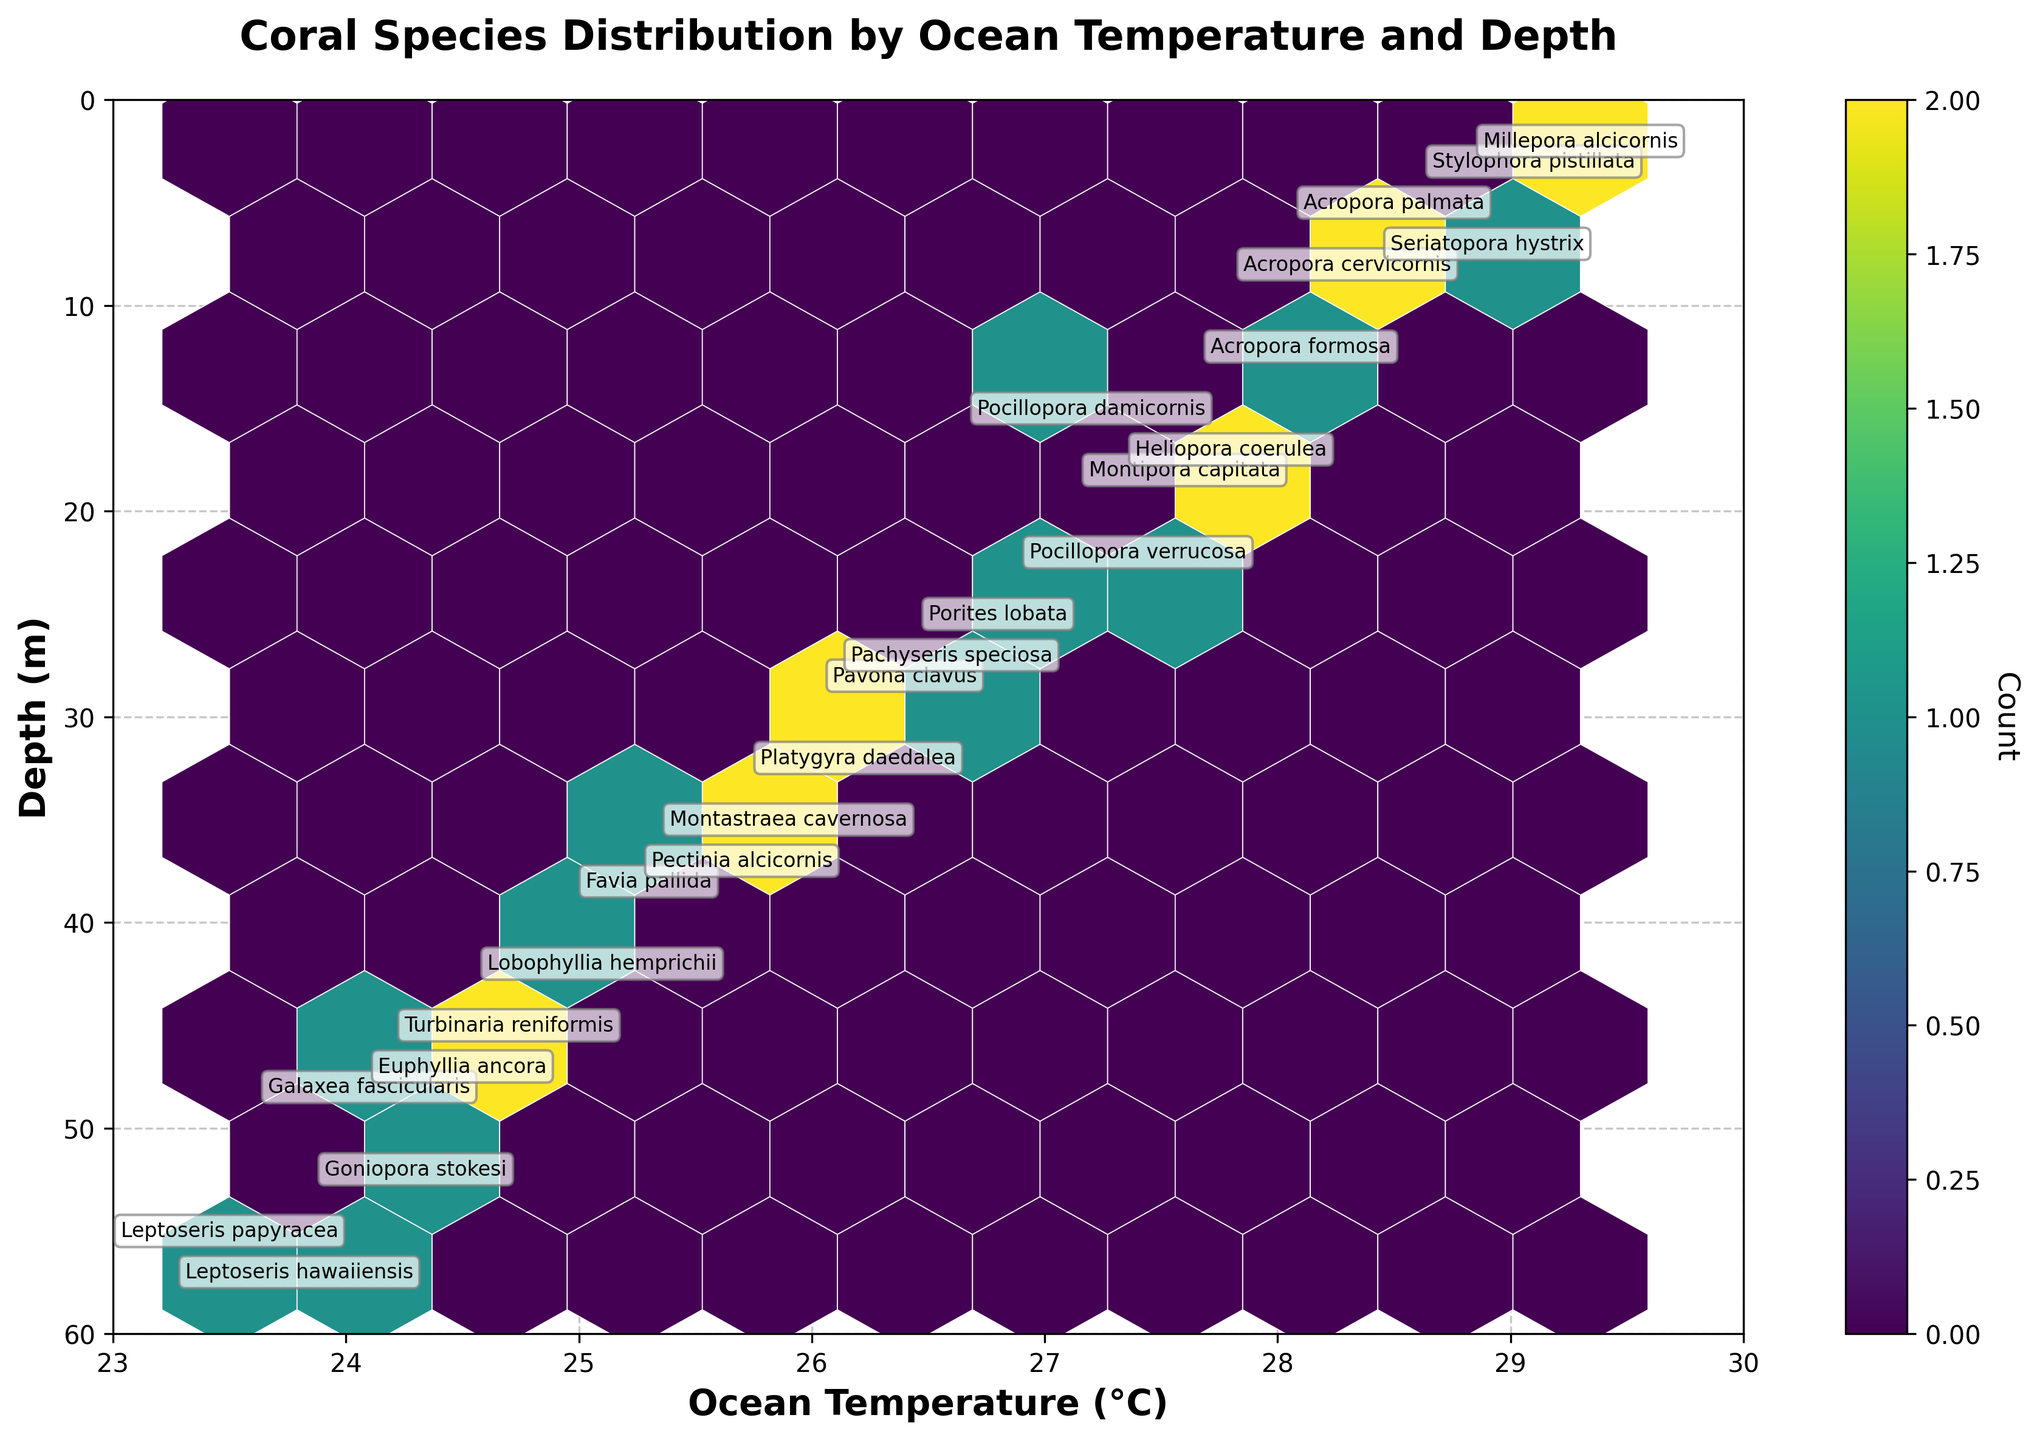What is the title of the plot? The title is always placed at the top center of the plot. In this case, it is written in bold and larger font to stand out and convey the main subject of the data visualization.
Answer: Coral Species Distribution by Ocean Temperature and Depth What are the axes labels and their units? The x-axis label is "Ocean Temperature (°C)" showing temperature in degrees Celsius, and the y-axis label is "Depth (m)" showing depth in meters. Generally, axis labels provide context for what each axis represents in the plot.
Answer: Ocean Temperature (°C) and Depth (m) How many bins are in the hexbin plot? Counting the number of hexagonal cells displayed, taking into account the grid size defined in the plot scenario. Each hexagon can be seen where data points are aggregated based on proximity.
Answer: 10 Which coral species appears deepest in the plot? By looking at the plot vertically down to find the lowest y-axis value where a species annotation is present, you can determine the deepest occurring species.
Answer: Leptoseris hawaiiensis Which temperature range has the highest density of corals? Identifying the temperature range with the most densely packed bins; areas where hexagons are darkest or most concentrated. This requires analyzing the coloration intensity of the hexagonal bins along the x-axis.
Answer: 27°C to 29°C Which coral species is found at the shallowest depth? Observing the highest point on the y-axis where a species annotation is made will indicate the shallowest depth of a particular species.
Answer: Millepora alcicornis Compare the distribution pattern of corals at 28°C versus 24°C. By focusing on the points and hexbin densities at the mentioned temperatures, observe where and how the corals are distributed across the depth, interpreting the concentration and spread.
Answer: At 28°C, corals are mostly found at shallower depths, while at 24°C, they tend to be present at deeper depths What is the average depth of corals at 26°C? Identify all the depths at which corals are present when the temperature is 26°C, then compute the arithmetic mean of these depths. There should be depths corresponding to corals annotated at these temperatures.
Answer: (25 + 27 + 28 + 32) / 4 = 28 m Which temperature and depth combination has multiple species annotations? Look for locations on the plot where more than one species name is written at the same or closely approximate temperature and depth coordinates. This indicates a shared habitat preference among those species.
Answer: 28.1°C and 12 m Does a higher ocean temperature correlate with a decrease in depth of coral distribution? Examine the overall trend by comparing depths across the range of temperatures. The general tendency of the depths which correspond to increasing temperatures will provide evidence of correlation.
Answer: Higher temperatures typically correlate with shallower depths 